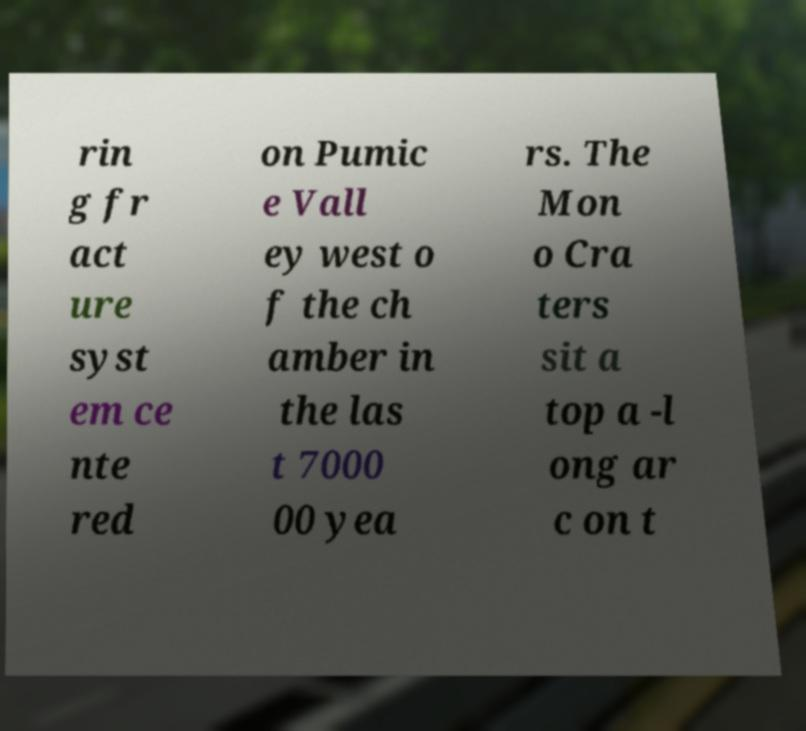Can you read and provide the text displayed in the image?This photo seems to have some interesting text. Can you extract and type it out for me? rin g fr act ure syst em ce nte red on Pumic e Vall ey west o f the ch amber in the las t 7000 00 yea rs. The Mon o Cra ters sit a top a -l ong ar c on t 